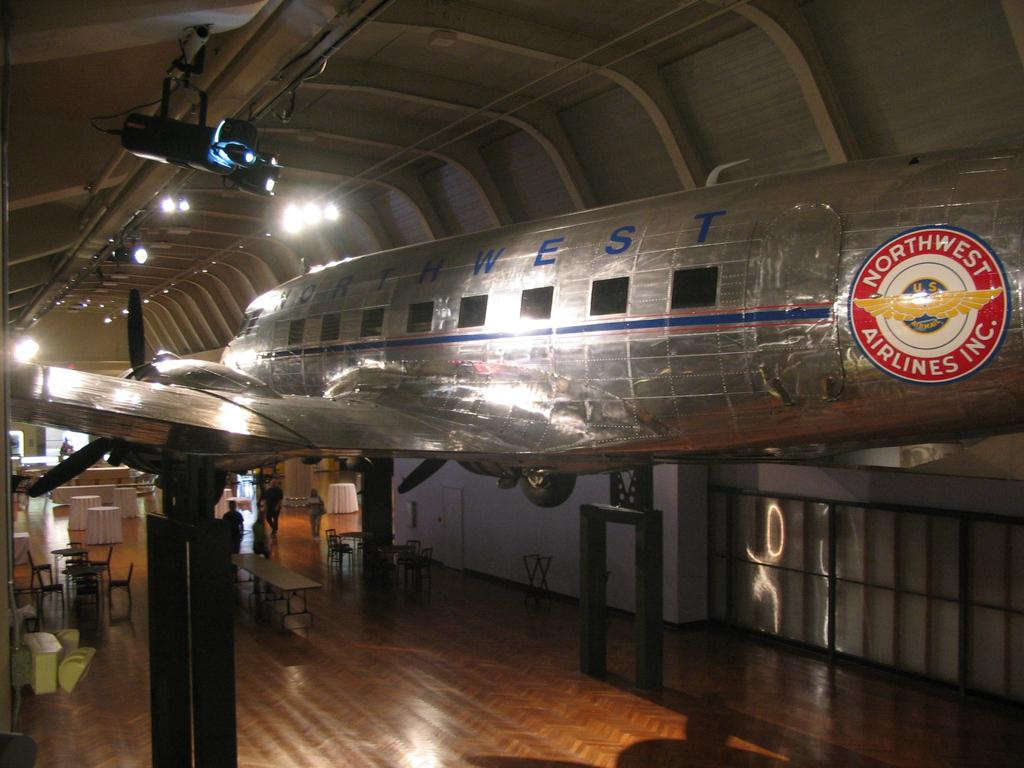<image>
Give a short and clear explanation of the subsequent image. A largeish airplane with Northwest  towards the  tail 